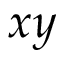<formula> <loc_0><loc_0><loc_500><loc_500>x y</formula> 